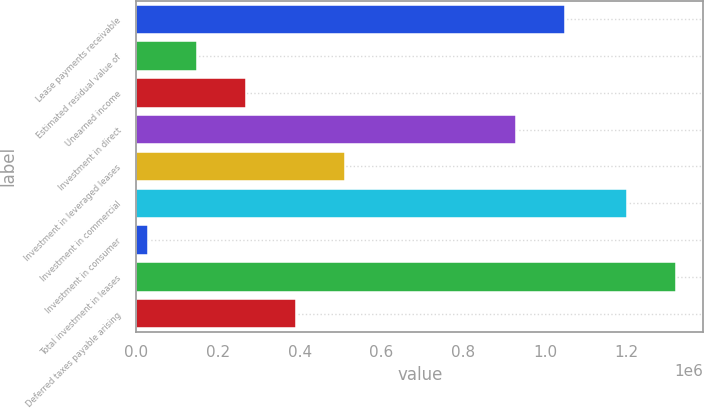Convert chart to OTSL. <chart><loc_0><loc_0><loc_500><loc_500><bar_chart><fcel>Lease payments receivable<fcel>Estimated residual value of<fcel>Unearned income<fcel>Investment in direct<fcel>Investment in leveraged leases<fcel>Investment in commercial<fcel>Investment in consumer<fcel>Total investment in leases<fcel>Deferred taxes payable arising<nl><fcel>1.04878e+06<fcel>149513<fcel>269613<fcel>928683<fcel>509814<fcel>1.201e+06<fcel>29413<fcel>1.3211e+06<fcel>389714<nl></chart> 